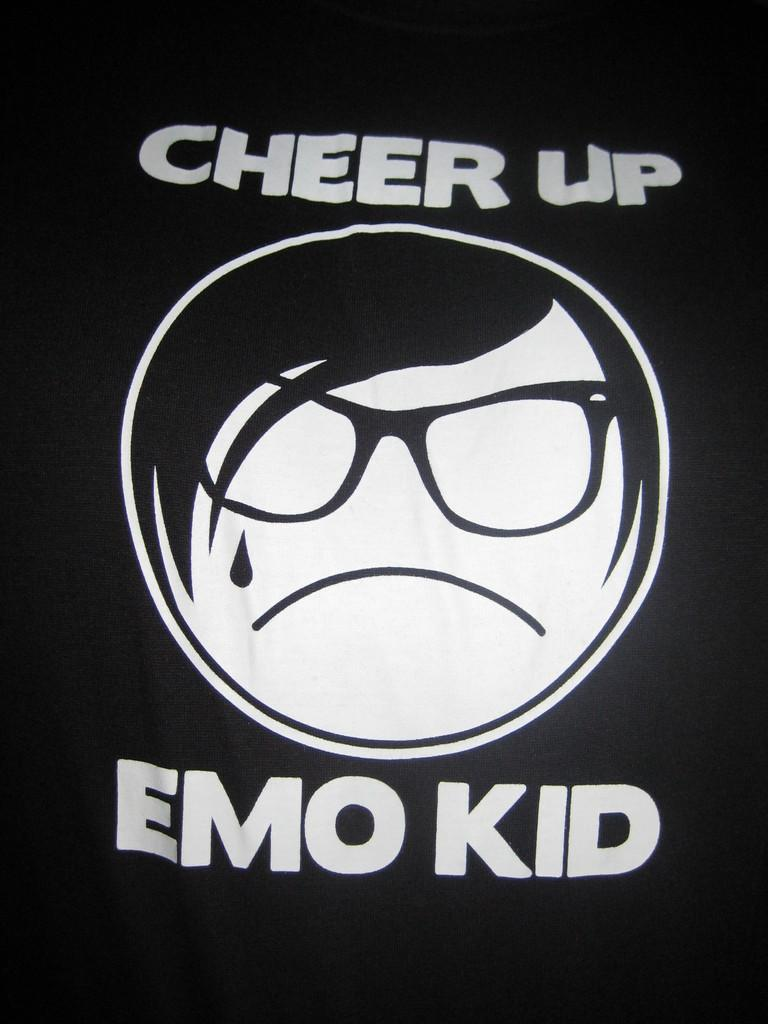What is depicted in the print of words in the image? The specific content of the print of words cannot be determined from the provided facts. What can be seen in addition to the print of words in the image? There is a person's face in the image. Are the print of words and the person's face part of the same item? Yes, both the print of words and the person's face are on an item. How many corks are visible in the image? There is no mention of corks in the provided facts, so it cannot be determined if any are present in the image. 